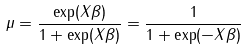Convert formula to latex. <formula><loc_0><loc_0><loc_500><loc_500>\mu = { \frac { \exp ( X { \beta } ) } { 1 + \exp ( X { \beta } ) } } = { \frac { 1 } { 1 + \exp ( - X { \beta } ) } } \,</formula> 